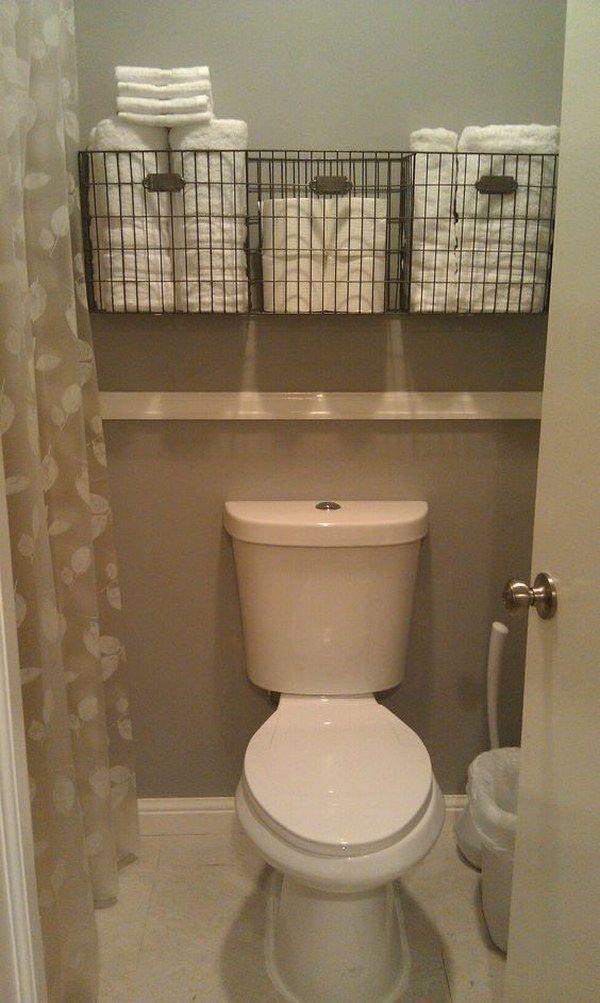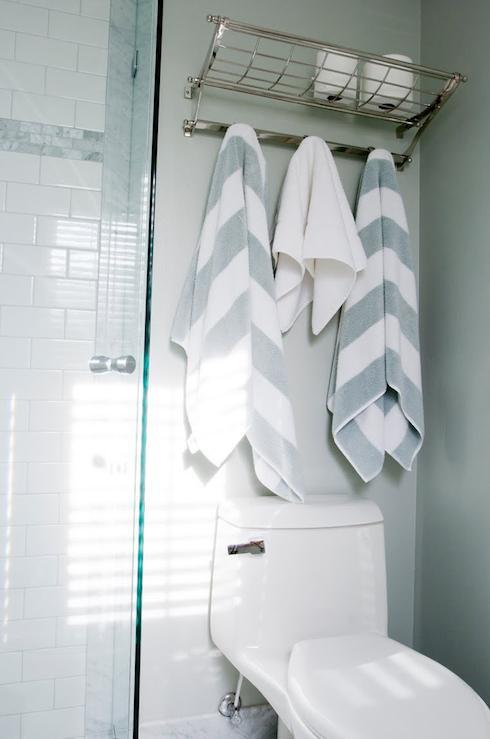The first image is the image on the left, the second image is the image on the right. Considering the images on both sides, is "There is at least part of a toilet shown." valid? Answer yes or no. Yes. 